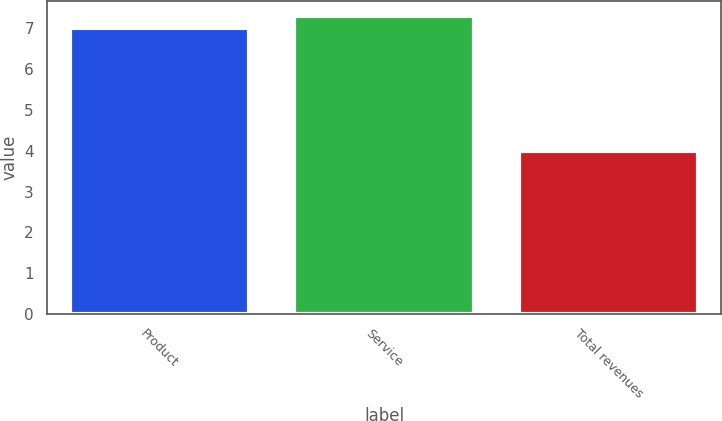Convert chart to OTSL. <chart><loc_0><loc_0><loc_500><loc_500><bar_chart><fcel>Product<fcel>Service<fcel>Total revenues<nl><fcel>7<fcel>7.3<fcel>4<nl></chart> 